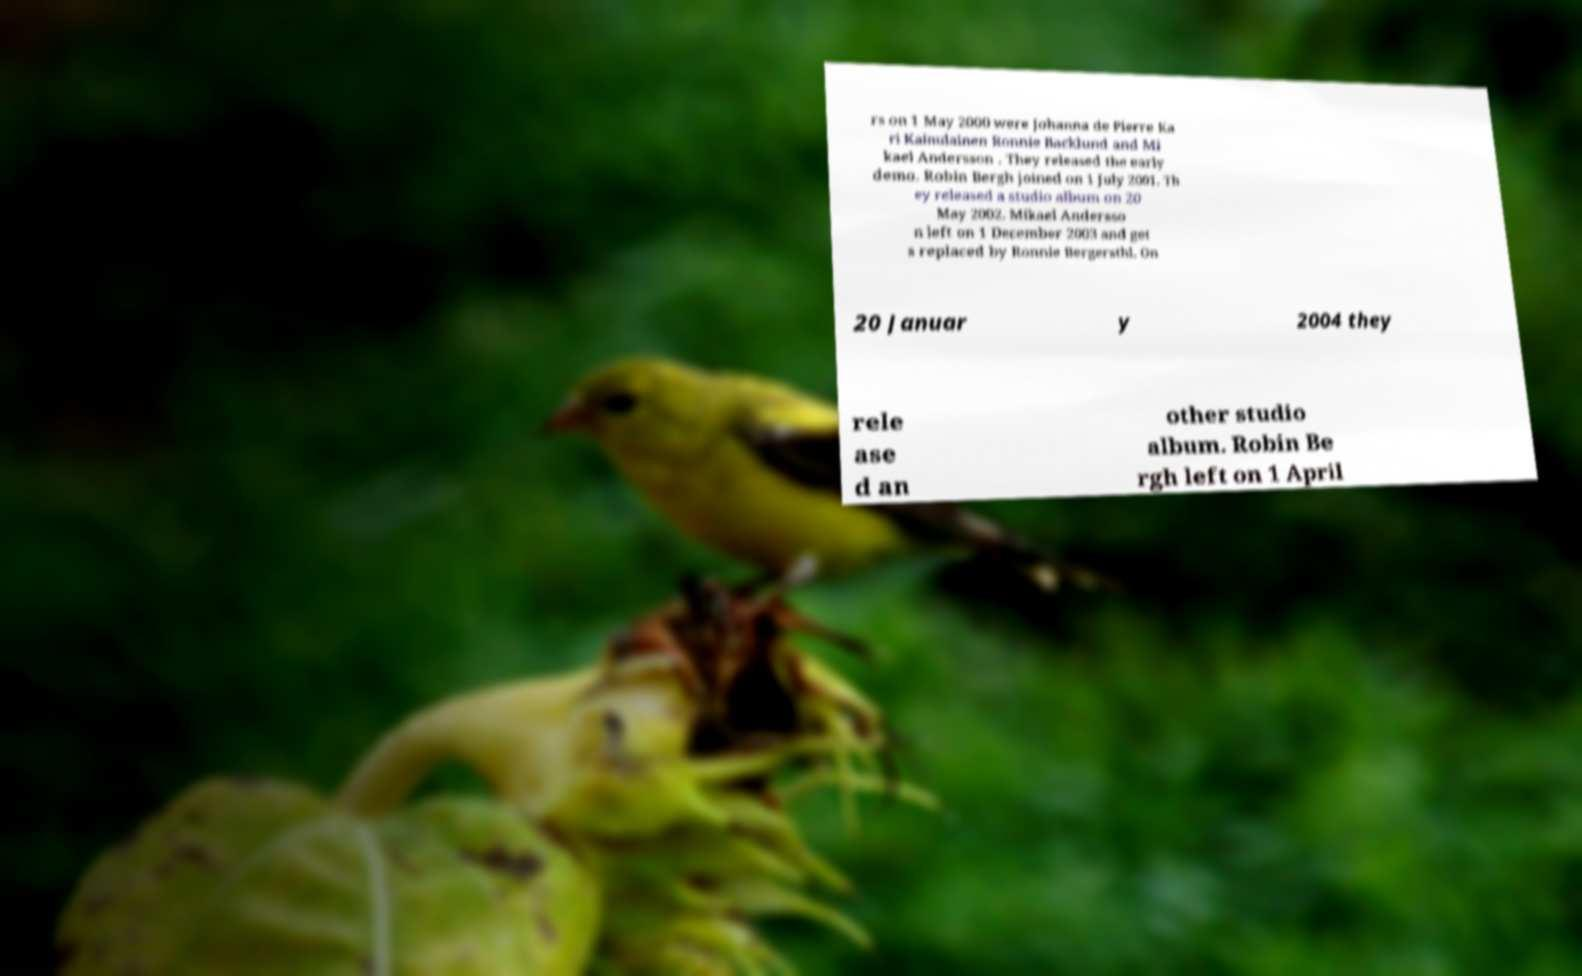Please identify and transcribe the text found in this image. rs on 1 May 2000 were Johanna de Pierre Ka ri Kainulainen Ronnie Backlund and Mi kael Andersson . They released the early demo. Robin Bergh joined on 1 July 2001. Th ey released a studio album on 20 May 2002. Mikael Andersso n left on 1 December 2003 and get s replaced by Ronnie Bergersthl. On 20 Januar y 2004 they rele ase d an other studio album. Robin Be rgh left on 1 April 